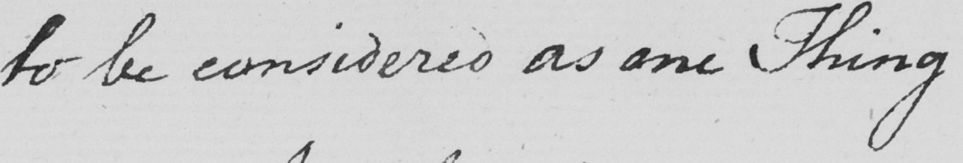What is written in this line of handwriting? to be considered as one Thing 